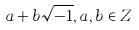<formula> <loc_0><loc_0><loc_500><loc_500>a + b \sqrt { - 1 } , a , b \in Z</formula> 